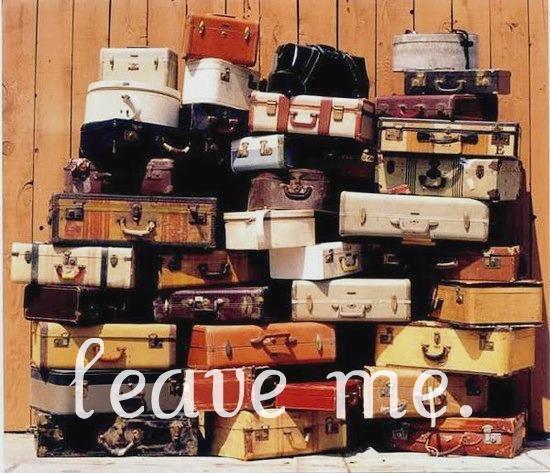How many suitcases are there?
Give a very brief answer. 13. 